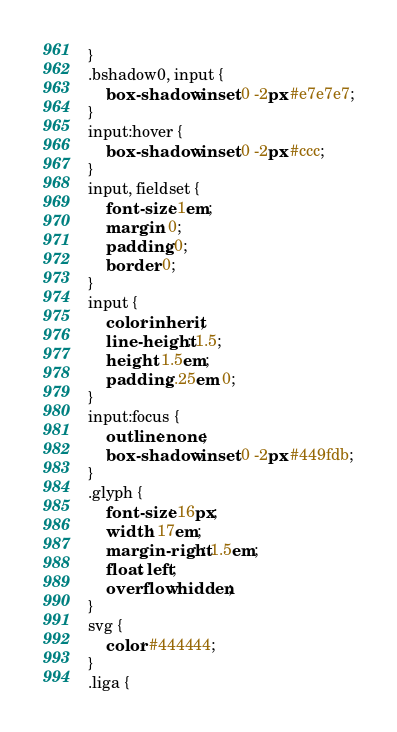Convert code to text. <code><loc_0><loc_0><loc_500><loc_500><_CSS_>}
.bshadow0, input {
	box-shadow: inset 0 -2px #e7e7e7;
}
input:hover {
	box-shadow: inset 0 -2px #ccc;
}
input, fieldset {
	font-size: 1em;
	margin: 0;
	padding: 0;
	border: 0;
}
input {
	color: inherit;
	line-height: 1.5;
	height: 1.5em;
	padding: .25em 0;
}
input:focus {
	outline: none;
	box-shadow: inset 0 -2px #449fdb;
}
.glyph {
	font-size: 16px;
	width: 17em;
	margin-right: 1.5em;
	float: left;
	overflow: hidden;
}
svg {
	color: #444444;
}
.liga {</code> 